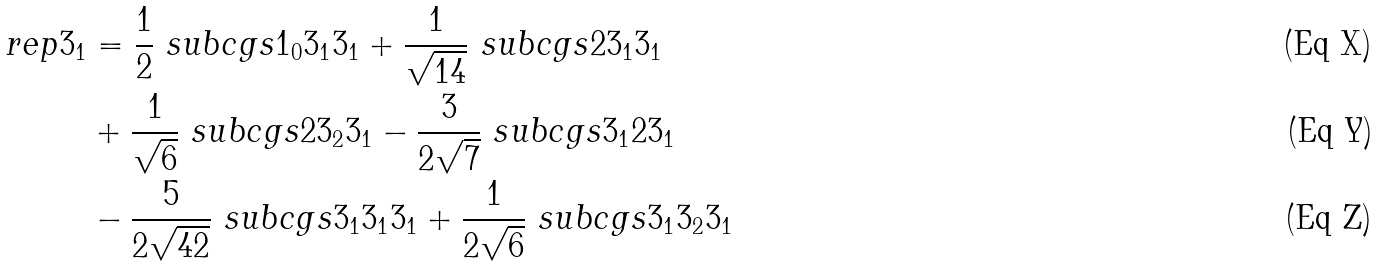Convert formula to latex. <formula><loc_0><loc_0><loc_500><loc_500>\ r e p { 3 } _ { 1 } & = \frac { 1 } { 2 } \ s u b c g s { 1 _ { 0 } } { 3 _ { 1 } } { 3 _ { 1 } } + \frac { 1 } { \sqrt { 1 4 } } \ s u b c g s { 2 } { 3 _ { 1 } } { 3 _ { 1 } } \\ & + \frac { 1 } { \sqrt { 6 } } \ s u b c g s { 2 } { 3 _ { 2 } } { 3 _ { 1 } } - \frac { 3 } { 2 \sqrt { 7 } } \ s u b c g s { 3 _ { 1 } } { 2 } { 3 _ { 1 } } \\ & - \frac { 5 } { 2 \sqrt { 4 2 } } \ s u b c g s { 3 _ { 1 } } { 3 _ { 1 } } { 3 _ { 1 } } + \frac { 1 } { 2 \sqrt { 6 } } \ s u b c g s { 3 _ { 1 } } { 3 _ { 2 } } { 3 _ { 1 } }</formula> 